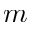Convert formula to latex. <formula><loc_0><loc_0><loc_500><loc_500>m</formula> 